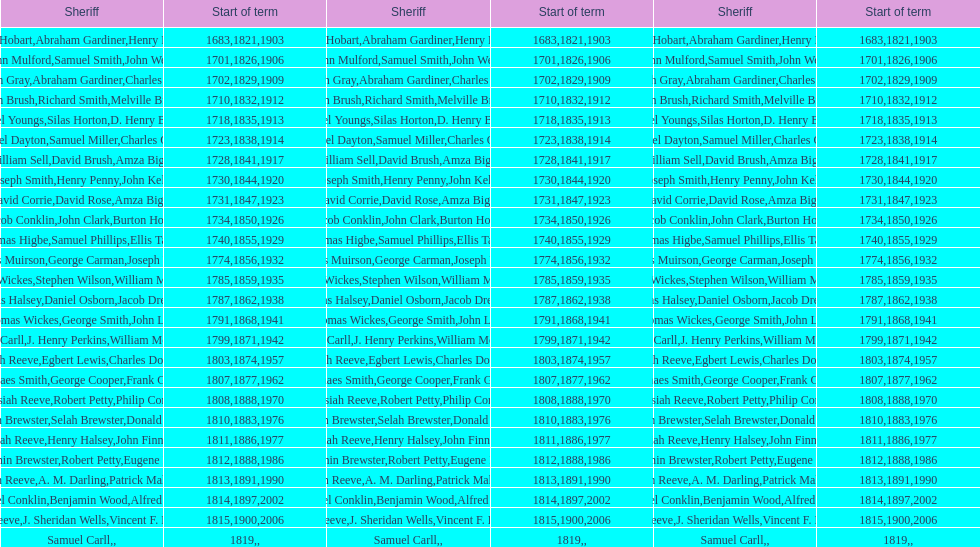Which sheriff came before thomas wickes? James Muirson. 